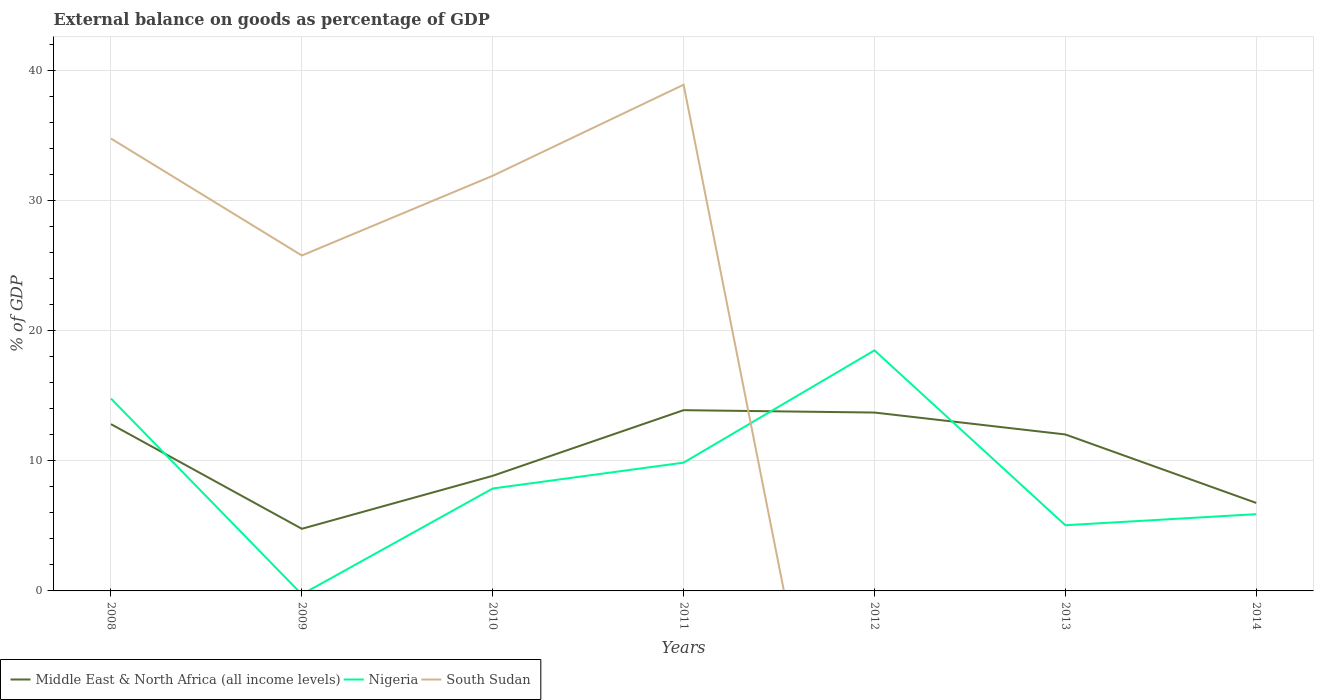Does the line corresponding to Middle East & North Africa (all income levels) intersect with the line corresponding to Nigeria?
Offer a terse response. Yes. Is the number of lines equal to the number of legend labels?
Provide a short and direct response. No. Across all years, what is the maximum external balance on goods as percentage of GDP in Middle East & North Africa (all income levels)?
Give a very brief answer. 4.78. What is the total external balance on goods as percentage of GDP in Middle East & North Africa (all income levels) in the graph?
Give a very brief answer. -1.99. What is the difference between the highest and the second highest external balance on goods as percentage of GDP in South Sudan?
Offer a very short reply. 38.93. What is the difference between the highest and the lowest external balance on goods as percentage of GDP in Nigeria?
Keep it short and to the point. 3. How many years are there in the graph?
Provide a succinct answer. 7. Are the values on the major ticks of Y-axis written in scientific E-notation?
Keep it short and to the point. No. How are the legend labels stacked?
Your answer should be compact. Horizontal. What is the title of the graph?
Keep it short and to the point. External balance on goods as percentage of GDP. Does "Equatorial Guinea" appear as one of the legend labels in the graph?
Provide a succinct answer. No. What is the label or title of the Y-axis?
Keep it short and to the point. % of GDP. What is the % of GDP in Middle East & North Africa (all income levels) in 2008?
Your answer should be compact. 12.83. What is the % of GDP in Nigeria in 2008?
Keep it short and to the point. 14.79. What is the % of GDP of South Sudan in 2008?
Your response must be concise. 34.79. What is the % of GDP of Middle East & North Africa (all income levels) in 2009?
Ensure brevity in your answer.  4.78. What is the % of GDP in Nigeria in 2009?
Your answer should be compact. 0. What is the % of GDP of South Sudan in 2009?
Your response must be concise. 25.79. What is the % of GDP in Middle East & North Africa (all income levels) in 2010?
Give a very brief answer. 8.85. What is the % of GDP in Nigeria in 2010?
Your answer should be very brief. 7.88. What is the % of GDP of South Sudan in 2010?
Your answer should be very brief. 31.93. What is the % of GDP of Middle East & North Africa (all income levels) in 2011?
Offer a terse response. 13.9. What is the % of GDP of Nigeria in 2011?
Provide a short and direct response. 9.87. What is the % of GDP in South Sudan in 2011?
Provide a succinct answer. 38.93. What is the % of GDP in Middle East & North Africa (all income levels) in 2012?
Your answer should be compact. 13.72. What is the % of GDP of Nigeria in 2012?
Offer a terse response. 18.5. What is the % of GDP of Middle East & North Africa (all income levels) in 2013?
Provide a short and direct response. 12.03. What is the % of GDP of Nigeria in 2013?
Your answer should be compact. 5.05. What is the % of GDP of South Sudan in 2013?
Provide a succinct answer. 0. What is the % of GDP in Middle East & North Africa (all income levels) in 2014?
Provide a short and direct response. 6.77. What is the % of GDP in Nigeria in 2014?
Make the answer very short. 5.9. Across all years, what is the maximum % of GDP in Middle East & North Africa (all income levels)?
Provide a succinct answer. 13.9. Across all years, what is the maximum % of GDP of Nigeria?
Make the answer very short. 18.5. Across all years, what is the maximum % of GDP in South Sudan?
Offer a very short reply. 38.93. Across all years, what is the minimum % of GDP of Middle East & North Africa (all income levels)?
Your answer should be compact. 4.78. Across all years, what is the minimum % of GDP in South Sudan?
Make the answer very short. 0. What is the total % of GDP in Middle East & North Africa (all income levels) in the graph?
Ensure brevity in your answer.  72.87. What is the total % of GDP in Nigeria in the graph?
Keep it short and to the point. 61.99. What is the total % of GDP of South Sudan in the graph?
Give a very brief answer. 131.43. What is the difference between the % of GDP of Middle East & North Africa (all income levels) in 2008 and that in 2009?
Ensure brevity in your answer.  8.05. What is the difference between the % of GDP in South Sudan in 2008 and that in 2009?
Keep it short and to the point. 8.99. What is the difference between the % of GDP in Middle East & North Africa (all income levels) in 2008 and that in 2010?
Offer a very short reply. 3.97. What is the difference between the % of GDP of Nigeria in 2008 and that in 2010?
Offer a very short reply. 6.92. What is the difference between the % of GDP in South Sudan in 2008 and that in 2010?
Ensure brevity in your answer.  2.86. What is the difference between the % of GDP in Middle East & North Africa (all income levels) in 2008 and that in 2011?
Your answer should be very brief. -1.07. What is the difference between the % of GDP of Nigeria in 2008 and that in 2011?
Offer a very short reply. 4.93. What is the difference between the % of GDP in South Sudan in 2008 and that in 2011?
Your response must be concise. -4.14. What is the difference between the % of GDP of Middle East & North Africa (all income levels) in 2008 and that in 2012?
Offer a very short reply. -0.89. What is the difference between the % of GDP of Nigeria in 2008 and that in 2012?
Offer a very short reply. -3.7. What is the difference between the % of GDP of Middle East & North Africa (all income levels) in 2008 and that in 2013?
Your answer should be very brief. 0.79. What is the difference between the % of GDP in Nigeria in 2008 and that in 2013?
Your answer should be compact. 9.74. What is the difference between the % of GDP of Middle East & North Africa (all income levels) in 2008 and that in 2014?
Your answer should be very brief. 6.06. What is the difference between the % of GDP in Nigeria in 2008 and that in 2014?
Your answer should be very brief. 8.89. What is the difference between the % of GDP of Middle East & North Africa (all income levels) in 2009 and that in 2010?
Your answer should be compact. -4.07. What is the difference between the % of GDP of South Sudan in 2009 and that in 2010?
Ensure brevity in your answer.  -6.13. What is the difference between the % of GDP in Middle East & North Africa (all income levels) in 2009 and that in 2011?
Your response must be concise. -9.12. What is the difference between the % of GDP of South Sudan in 2009 and that in 2011?
Offer a very short reply. -13.13. What is the difference between the % of GDP of Middle East & North Africa (all income levels) in 2009 and that in 2012?
Provide a succinct answer. -8.94. What is the difference between the % of GDP in Middle East & North Africa (all income levels) in 2009 and that in 2013?
Offer a very short reply. -7.25. What is the difference between the % of GDP of Middle East & North Africa (all income levels) in 2009 and that in 2014?
Offer a terse response. -1.99. What is the difference between the % of GDP in Middle East & North Africa (all income levels) in 2010 and that in 2011?
Ensure brevity in your answer.  -5.05. What is the difference between the % of GDP of Nigeria in 2010 and that in 2011?
Give a very brief answer. -1.99. What is the difference between the % of GDP of South Sudan in 2010 and that in 2011?
Ensure brevity in your answer.  -7. What is the difference between the % of GDP in Middle East & North Africa (all income levels) in 2010 and that in 2012?
Ensure brevity in your answer.  -4.87. What is the difference between the % of GDP in Nigeria in 2010 and that in 2012?
Your response must be concise. -10.62. What is the difference between the % of GDP in Middle East & North Africa (all income levels) in 2010 and that in 2013?
Ensure brevity in your answer.  -3.18. What is the difference between the % of GDP of Nigeria in 2010 and that in 2013?
Your response must be concise. 2.83. What is the difference between the % of GDP in Middle East & North Africa (all income levels) in 2010 and that in 2014?
Give a very brief answer. 2.08. What is the difference between the % of GDP of Nigeria in 2010 and that in 2014?
Provide a succinct answer. 1.97. What is the difference between the % of GDP in Middle East & North Africa (all income levels) in 2011 and that in 2012?
Your answer should be very brief. 0.18. What is the difference between the % of GDP in Nigeria in 2011 and that in 2012?
Offer a terse response. -8.63. What is the difference between the % of GDP in Middle East & North Africa (all income levels) in 2011 and that in 2013?
Your answer should be very brief. 1.87. What is the difference between the % of GDP in Nigeria in 2011 and that in 2013?
Provide a succinct answer. 4.81. What is the difference between the % of GDP of Middle East & North Africa (all income levels) in 2011 and that in 2014?
Your answer should be very brief. 7.13. What is the difference between the % of GDP of Nigeria in 2011 and that in 2014?
Offer a terse response. 3.96. What is the difference between the % of GDP of Middle East & North Africa (all income levels) in 2012 and that in 2013?
Ensure brevity in your answer.  1.69. What is the difference between the % of GDP of Nigeria in 2012 and that in 2013?
Offer a very short reply. 13.45. What is the difference between the % of GDP in Middle East & North Africa (all income levels) in 2012 and that in 2014?
Your response must be concise. 6.95. What is the difference between the % of GDP in Nigeria in 2012 and that in 2014?
Provide a succinct answer. 12.6. What is the difference between the % of GDP of Middle East & North Africa (all income levels) in 2013 and that in 2014?
Give a very brief answer. 5.26. What is the difference between the % of GDP of Nigeria in 2013 and that in 2014?
Your response must be concise. -0.85. What is the difference between the % of GDP in Middle East & North Africa (all income levels) in 2008 and the % of GDP in South Sudan in 2009?
Ensure brevity in your answer.  -12.97. What is the difference between the % of GDP of Nigeria in 2008 and the % of GDP of South Sudan in 2009?
Ensure brevity in your answer.  -11. What is the difference between the % of GDP of Middle East & North Africa (all income levels) in 2008 and the % of GDP of Nigeria in 2010?
Offer a terse response. 4.95. What is the difference between the % of GDP in Middle East & North Africa (all income levels) in 2008 and the % of GDP in South Sudan in 2010?
Provide a short and direct response. -19.1. What is the difference between the % of GDP of Nigeria in 2008 and the % of GDP of South Sudan in 2010?
Keep it short and to the point. -17.13. What is the difference between the % of GDP in Middle East & North Africa (all income levels) in 2008 and the % of GDP in Nigeria in 2011?
Provide a short and direct response. 2.96. What is the difference between the % of GDP of Middle East & North Africa (all income levels) in 2008 and the % of GDP of South Sudan in 2011?
Your answer should be compact. -26.1. What is the difference between the % of GDP in Nigeria in 2008 and the % of GDP in South Sudan in 2011?
Provide a short and direct response. -24.13. What is the difference between the % of GDP in Middle East & North Africa (all income levels) in 2008 and the % of GDP in Nigeria in 2012?
Offer a terse response. -5.67. What is the difference between the % of GDP of Middle East & North Africa (all income levels) in 2008 and the % of GDP of Nigeria in 2013?
Provide a short and direct response. 7.77. What is the difference between the % of GDP in Middle East & North Africa (all income levels) in 2008 and the % of GDP in Nigeria in 2014?
Your response must be concise. 6.92. What is the difference between the % of GDP of Middle East & North Africa (all income levels) in 2009 and the % of GDP of Nigeria in 2010?
Make the answer very short. -3.1. What is the difference between the % of GDP of Middle East & North Africa (all income levels) in 2009 and the % of GDP of South Sudan in 2010?
Your answer should be compact. -27.15. What is the difference between the % of GDP in Middle East & North Africa (all income levels) in 2009 and the % of GDP in Nigeria in 2011?
Keep it short and to the point. -5.09. What is the difference between the % of GDP of Middle East & North Africa (all income levels) in 2009 and the % of GDP of South Sudan in 2011?
Your answer should be compact. -34.15. What is the difference between the % of GDP in Middle East & North Africa (all income levels) in 2009 and the % of GDP in Nigeria in 2012?
Ensure brevity in your answer.  -13.72. What is the difference between the % of GDP in Middle East & North Africa (all income levels) in 2009 and the % of GDP in Nigeria in 2013?
Offer a terse response. -0.27. What is the difference between the % of GDP in Middle East & North Africa (all income levels) in 2009 and the % of GDP in Nigeria in 2014?
Offer a very short reply. -1.12. What is the difference between the % of GDP of Middle East & North Africa (all income levels) in 2010 and the % of GDP of Nigeria in 2011?
Offer a terse response. -1.01. What is the difference between the % of GDP in Middle East & North Africa (all income levels) in 2010 and the % of GDP in South Sudan in 2011?
Give a very brief answer. -30.07. What is the difference between the % of GDP of Nigeria in 2010 and the % of GDP of South Sudan in 2011?
Ensure brevity in your answer.  -31.05. What is the difference between the % of GDP in Middle East & North Africa (all income levels) in 2010 and the % of GDP in Nigeria in 2012?
Provide a short and direct response. -9.65. What is the difference between the % of GDP in Middle East & North Africa (all income levels) in 2010 and the % of GDP in Nigeria in 2013?
Keep it short and to the point. 3.8. What is the difference between the % of GDP of Middle East & North Africa (all income levels) in 2010 and the % of GDP of Nigeria in 2014?
Give a very brief answer. 2.95. What is the difference between the % of GDP of Middle East & North Africa (all income levels) in 2011 and the % of GDP of Nigeria in 2012?
Give a very brief answer. -4.6. What is the difference between the % of GDP in Middle East & North Africa (all income levels) in 2011 and the % of GDP in Nigeria in 2013?
Offer a terse response. 8.85. What is the difference between the % of GDP in Middle East & North Africa (all income levels) in 2011 and the % of GDP in Nigeria in 2014?
Your answer should be very brief. 8. What is the difference between the % of GDP of Middle East & North Africa (all income levels) in 2012 and the % of GDP of Nigeria in 2013?
Your answer should be very brief. 8.67. What is the difference between the % of GDP in Middle East & North Africa (all income levels) in 2012 and the % of GDP in Nigeria in 2014?
Make the answer very short. 7.82. What is the difference between the % of GDP of Middle East & North Africa (all income levels) in 2013 and the % of GDP of Nigeria in 2014?
Provide a short and direct response. 6.13. What is the average % of GDP of Middle East & North Africa (all income levels) per year?
Offer a very short reply. 10.41. What is the average % of GDP of Nigeria per year?
Offer a very short reply. 8.86. What is the average % of GDP of South Sudan per year?
Offer a very short reply. 18.78. In the year 2008, what is the difference between the % of GDP in Middle East & North Africa (all income levels) and % of GDP in Nigeria?
Provide a short and direct response. -1.97. In the year 2008, what is the difference between the % of GDP in Middle East & North Africa (all income levels) and % of GDP in South Sudan?
Your response must be concise. -21.96. In the year 2008, what is the difference between the % of GDP of Nigeria and % of GDP of South Sudan?
Ensure brevity in your answer.  -19.99. In the year 2009, what is the difference between the % of GDP in Middle East & North Africa (all income levels) and % of GDP in South Sudan?
Offer a very short reply. -21.02. In the year 2010, what is the difference between the % of GDP in Middle East & North Africa (all income levels) and % of GDP in Nigeria?
Your answer should be compact. 0.97. In the year 2010, what is the difference between the % of GDP in Middle East & North Africa (all income levels) and % of GDP in South Sudan?
Ensure brevity in your answer.  -23.07. In the year 2010, what is the difference between the % of GDP of Nigeria and % of GDP of South Sudan?
Provide a succinct answer. -24.05. In the year 2011, what is the difference between the % of GDP of Middle East & North Africa (all income levels) and % of GDP of Nigeria?
Offer a terse response. 4.03. In the year 2011, what is the difference between the % of GDP of Middle East & North Africa (all income levels) and % of GDP of South Sudan?
Give a very brief answer. -25.03. In the year 2011, what is the difference between the % of GDP of Nigeria and % of GDP of South Sudan?
Offer a very short reply. -29.06. In the year 2012, what is the difference between the % of GDP of Middle East & North Africa (all income levels) and % of GDP of Nigeria?
Your response must be concise. -4.78. In the year 2013, what is the difference between the % of GDP in Middle East & North Africa (all income levels) and % of GDP in Nigeria?
Offer a terse response. 6.98. In the year 2014, what is the difference between the % of GDP in Middle East & North Africa (all income levels) and % of GDP in Nigeria?
Offer a very short reply. 0.86. What is the ratio of the % of GDP of Middle East & North Africa (all income levels) in 2008 to that in 2009?
Provide a short and direct response. 2.68. What is the ratio of the % of GDP of South Sudan in 2008 to that in 2009?
Keep it short and to the point. 1.35. What is the ratio of the % of GDP of Middle East & North Africa (all income levels) in 2008 to that in 2010?
Give a very brief answer. 1.45. What is the ratio of the % of GDP of Nigeria in 2008 to that in 2010?
Offer a very short reply. 1.88. What is the ratio of the % of GDP in South Sudan in 2008 to that in 2010?
Ensure brevity in your answer.  1.09. What is the ratio of the % of GDP of Middle East & North Africa (all income levels) in 2008 to that in 2011?
Provide a short and direct response. 0.92. What is the ratio of the % of GDP of Nigeria in 2008 to that in 2011?
Make the answer very short. 1.5. What is the ratio of the % of GDP in South Sudan in 2008 to that in 2011?
Offer a terse response. 0.89. What is the ratio of the % of GDP in Middle East & North Africa (all income levels) in 2008 to that in 2012?
Ensure brevity in your answer.  0.94. What is the ratio of the % of GDP in Nigeria in 2008 to that in 2012?
Provide a succinct answer. 0.8. What is the ratio of the % of GDP in Middle East & North Africa (all income levels) in 2008 to that in 2013?
Offer a terse response. 1.07. What is the ratio of the % of GDP of Nigeria in 2008 to that in 2013?
Make the answer very short. 2.93. What is the ratio of the % of GDP in Middle East & North Africa (all income levels) in 2008 to that in 2014?
Offer a terse response. 1.9. What is the ratio of the % of GDP of Nigeria in 2008 to that in 2014?
Your response must be concise. 2.51. What is the ratio of the % of GDP in Middle East & North Africa (all income levels) in 2009 to that in 2010?
Make the answer very short. 0.54. What is the ratio of the % of GDP of South Sudan in 2009 to that in 2010?
Offer a terse response. 0.81. What is the ratio of the % of GDP in Middle East & North Africa (all income levels) in 2009 to that in 2011?
Your answer should be very brief. 0.34. What is the ratio of the % of GDP of South Sudan in 2009 to that in 2011?
Make the answer very short. 0.66. What is the ratio of the % of GDP in Middle East & North Africa (all income levels) in 2009 to that in 2012?
Keep it short and to the point. 0.35. What is the ratio of the % of GDP of Middle East & North Africa (all income levels) in 2009 to that in 2013?
Ensure brevity in your answer.  0.4. What is the ratio of the % of GDP in Middle East & North Africa (all income levels) in 2009 to that in 2014?
Your response must be concise. 0.71. What is the ratio of the % of GDP in Middle East & North Africa (all income levels) in 2010 to that in 2011?
Make the answer very short. 0.64. What is the ratio of the % of GDP in Nigeria in 2010 to that in 2011?
Give a very brief answer. 0.8. What is the ratio of the % of GDP of South Sudan in 2010 to that in 2011?
Offer a terse response. 0.82. What is the ratio of the % of GDP of Middle East & North Africa (all income levels) in 2010 to that in 2012?
Offer a very short reply. 0.65. What is the ratio of the % of GDP in Nigeria in 2010 to that in 2012?
Provide a short and direct response. 0.43. What is the ratio of the % of GDP in Middle East & North Africa (all income levels) in 2010 to that in 2013?
Keep it short and to the point. 0.74. What is the ratio of the % of GDP in Nigeria in 2010 to that in 2013?
Offer a terse response. 1.56. What is the ratio of the % of GDP in Middle East & North Africa (all income levels) in 2010 to that in 2014?
Offer a terse response. 1.31. What is the ratio of the % of GDP in Nigeria in 2010 to that in 2014?
Make the answer very short. 1.33. What is the ratio of the % of GDP of Middle East & North Africa (all income levels) in 2011 to that in 2012?
Ensure brevity in your answer.  1.01. What is the ratio of the % of GDP of Nigeria in 2011 to that in 2012?
Your answer should be very brief. 0.53. What is the ratio of the % of GDP of Middle East & North Africa (all income levels) in 2011 to that in 2013?
Make the answer very short. 1.16. What is the ratio of the % of GDP in Nigeria in 2011 to that in 2013?
Ensure brevity in your answer.  1.95. What is the ratio of the % of GDP of Middle East & North Africa (all income levels) in 2011 to that in 2014?
Provide a short and direct response. 2.05. What is the ratio of the % of GDP in Nigeria in 2011 to that in 2014?
Make the answer very short. 1.67. What is the ratio of the % of GDP in Middle East & North Africa (all income levels) in 2012 to that in 2013?
Give a very brief answer. 1.14. What is the ratio of the % of GDP in Nigeria in 2012 to that in 2013?
Your answer should be compact. 3.66. What is the ratio of the % of GDP in Middle East & North Africa (all income levels) in 2012 to that in 2014?
Make the answer very short. 2.03. What is the ratio of the % of GDP in Nigeria in 2012 to that in 2014?
Keep it short and to the point. 3.13. What is the ratio of the % of GDP in Middle East & North Africa (all income levels) in 2013 to that in 2014?
Your answer should be compact. 1.78. What is the ratio of the % of GDP in Nigeria in 2013 to that in 2014?
Give a very brief answer. 0.86. What is the difference between the highest and the second highest % of GDP in Middle East & North Africa (all income levels)?
Offer a very short reply. 0.18. What is the difference between the highest and the second highest % of GDP in Nigeria?
Your answer should be very brief. 3.7. What is the difference between the highest and the second highest % of GDP of South Sudan?
Provide a short and direct response. 4.14. What is the difference between the highest and the lowest % of GDP of Middle East & North Africa (all income levels)?
Offer a terse response. 9.12. What is the difference between the highest and the lowest % of GDP of Nigeria?
Give a very brief answer. 18.5. What is the difference between the highest and the lowest % of GDP of South Sudan?
Provide a short and direct response. 38.93. 